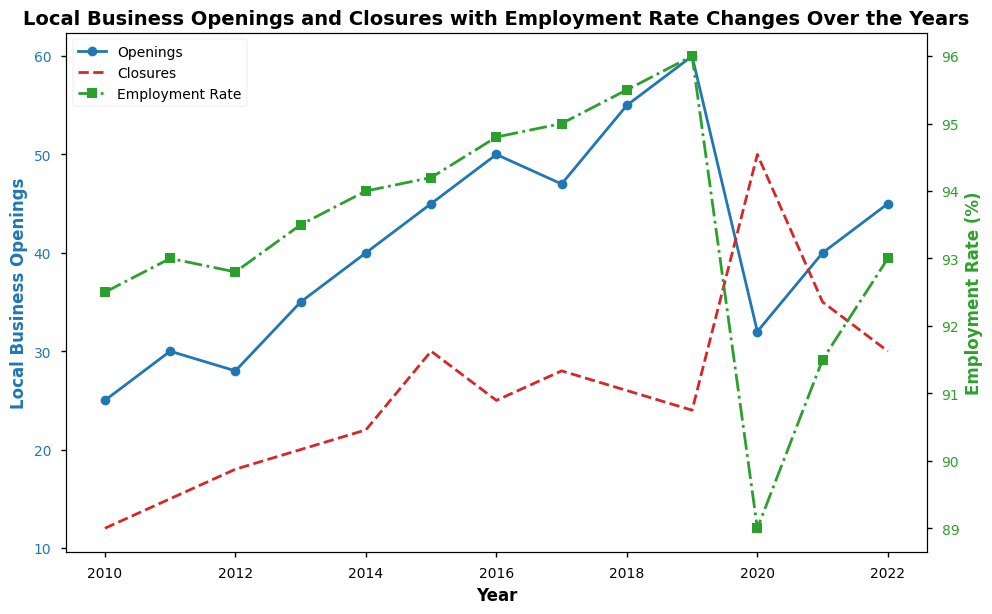Which year had the highest number of local business openings? Identify the highest point on the blue line representing 'Openings' by year. 2019 shows the peak.
Answer: 2019 What is the difference in local business openings between the year 2020 and the year 2019? Check the values for 'Openings' in 2019 and 2020, then calculate the difference: 60 (2019) - 32 (2020)
Answer: 28 In which year did the employment rate reach its maximum value? Find the peak value on the green line representing 'Employment Rate'. The highest employment rate is in 2019.
Answer: 2019 What was the average number of local business closures from 2010 to 2012? Add the closures values for 2010, 2011, and 2012, then divide by 3. (12+15+18) / 3 = 45 / 3
Answer: 15 During which year was the employment rate the lowest, and how does it correlate with the number of closures for the same year? Identify the year with the lowest green line value, which is 2020 with an employment rate of 89.0%. The closures for 2020 were 50, the highest among all years.
Answer: 2020, highest closures Comparing the trend between local business openings and employment rate, do they generally move together? Visually inspect both lines, blue for openings and green for employment rate. Generally, as openings increase (until 2019), the employment rate also increases.
Answer: Yes How did the number of local business closures change from 2019 to 2020? Subtract the closures in 2019 from those in 2020: 50 (2020) - 24 (2019)
Answer: 26 What was the percentage decrease in employment rate from 2019 to 2020? Calculate the percentage decrease from 96.0 (2019) to 89.0 (2020): ((96.0 - 89.0) / 96.0) * 100
Answer: 7.29% Which year had a higher number of openings, 2016 or 2022? Compare the openings value for both years, 50 in 2016 and 45 in 2022.
Answer: 2016 By how much did the employment rate increase from the year with the lowest closures to the year with the highest openings? The lowest closures were in 2010 (12) with an employment rate of 92.5%. The highest openings were in 2019 (60) with an employment rate of 96.0%. The increase: 96.0 - 92.5
Answer: 3.5% 